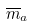<formula> <loc_0><loc_0><loc_500><loc_500>\overline { m } _ { a }</formula> 